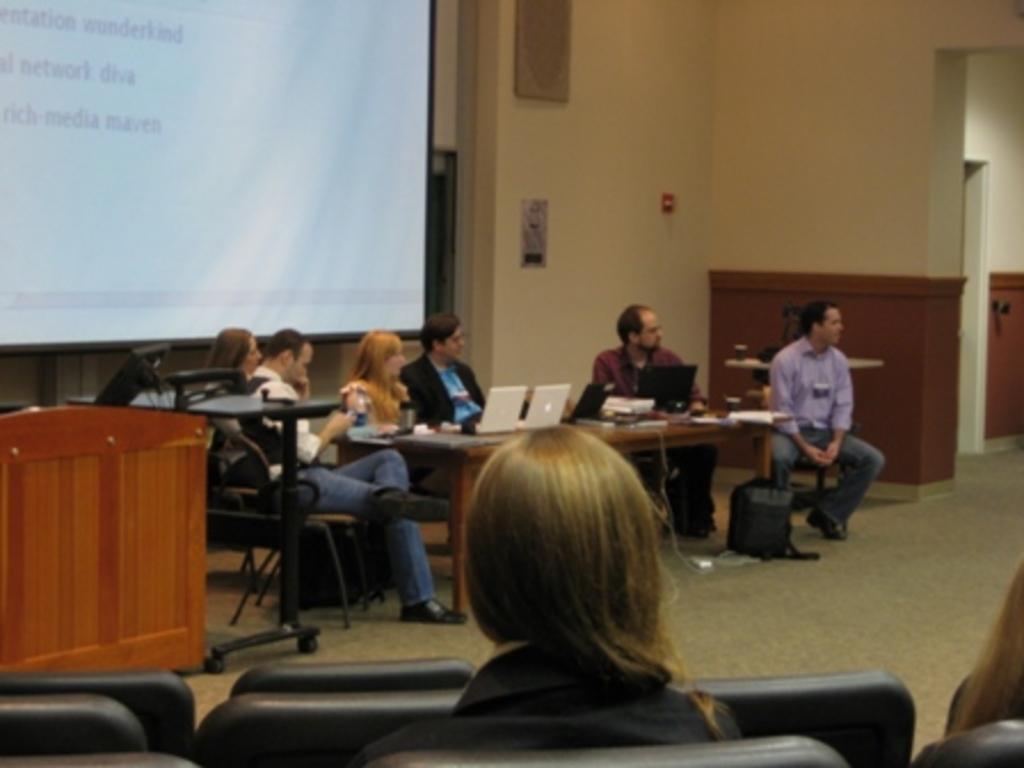Could you give a brief overview of what you see in this image? The picture is taken inside of the hall in which there are people sitting on the chairs in front of the table and on the table there are laptops,papers and water bottles and behind them there is a big screen and at the right corner there is one bench and a table and in front of them there are two people sitting on the chairs and at the right corner there is another room and behind them there is wall and some pictures on it. 